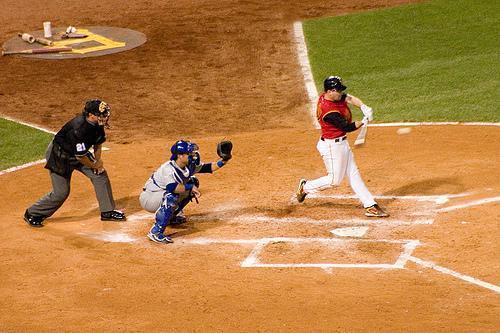How many people are in the photo?
Give a very brief answer. 3. How many birds are standing on the boat?
Give a very brief answer. 0. 